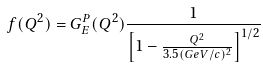Convert formula to latex. <formula><loc_0><loc_0><loc_500><loc_500>f ( Q ^ { 2 } ) = G _ { E } ^ { P } ( Q ^ { 2 } ) \frac { 1 } { \left [ 1 - \frac { Q ^ { 2 } } { 3 . 5 ( G e V / c ) ^ { 2 } } \right ] ^ { 1 / 2 } }</formula> 